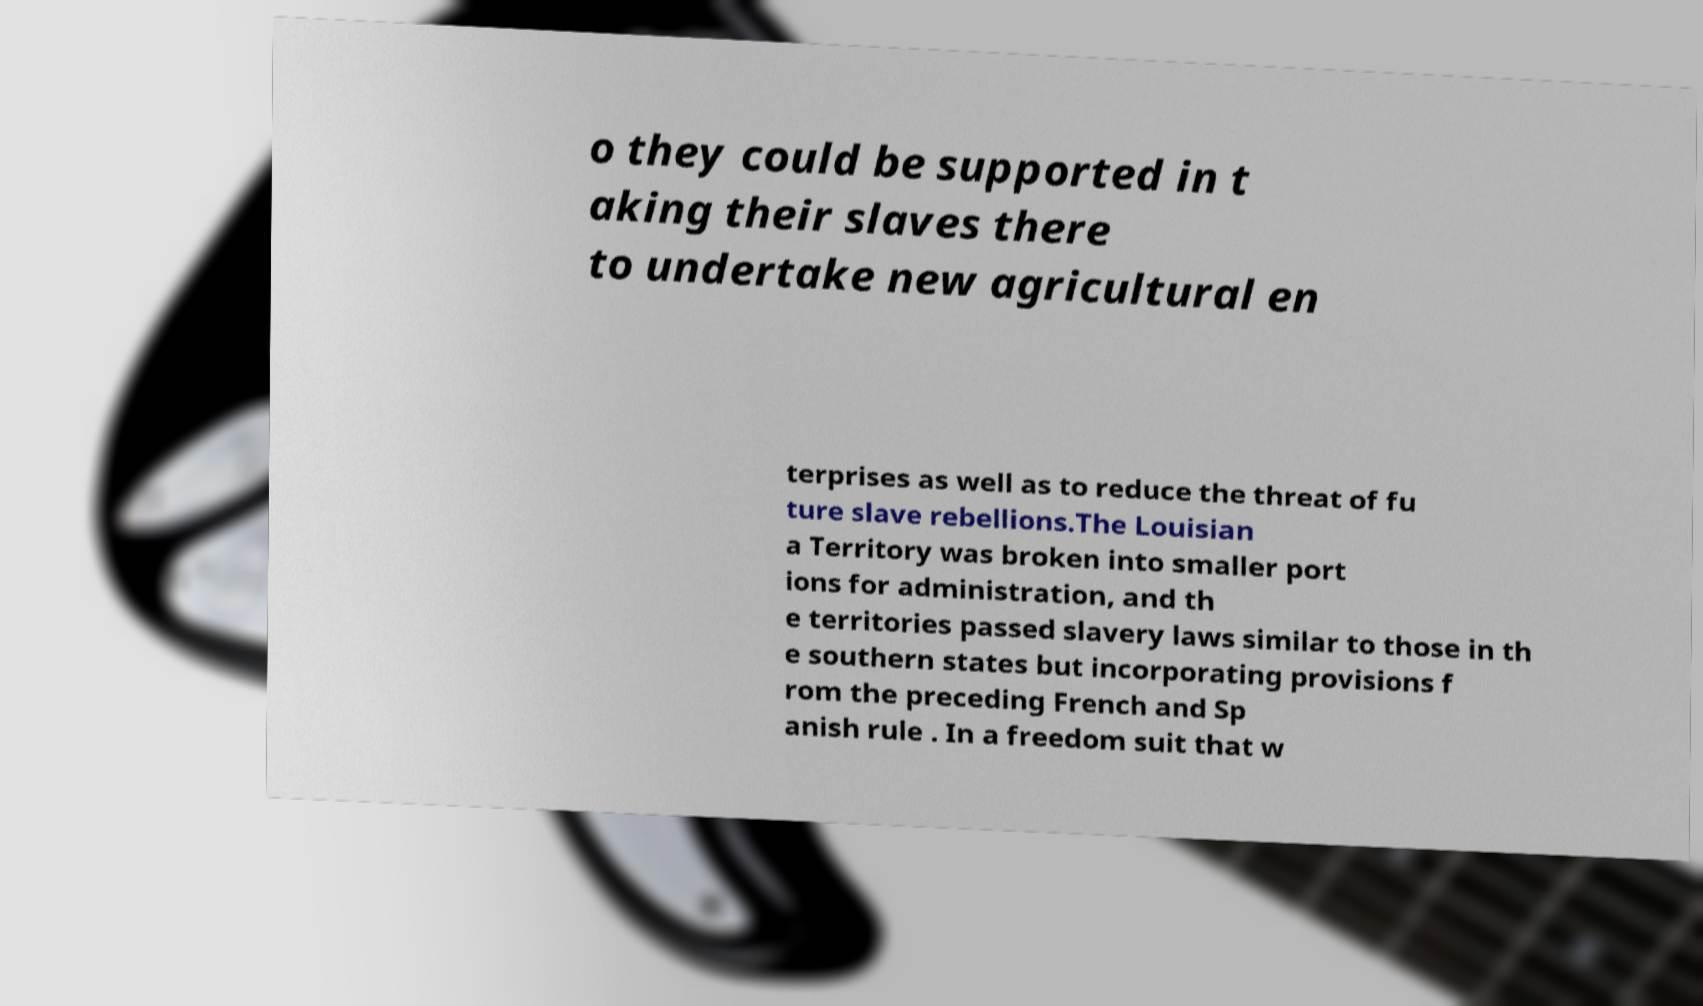For documentation purposes, I need the text within this image transcribed. Could you provide that? o they could be supported in t aking their slaves there to undertake new agricultural en terprises as well as to reduce the threat of fu ture slave rebellions.The Louisian a Territory was broken into smaller port ions for administration, and th e territories passed slavery laws similar to those in th e southern states but incorporating provisions f rom the preceding French and Sp anish rule . In a freedom suit that w 